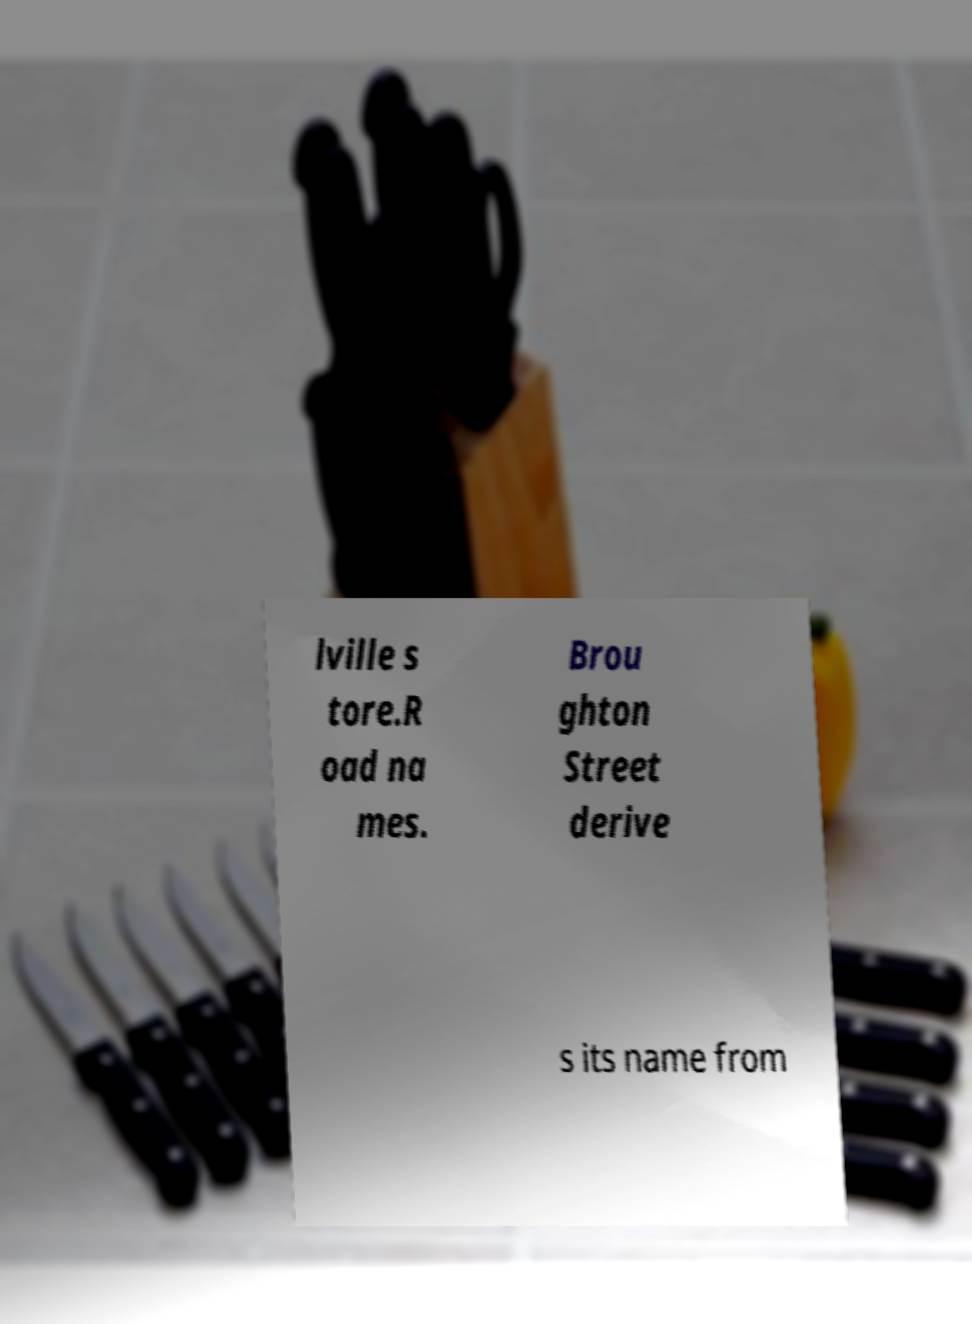For documentation purposes, I need the text within this image transcribed. Could you provide that? lville s tore.R oad na mes. Brou ghton Street derive s its name from 